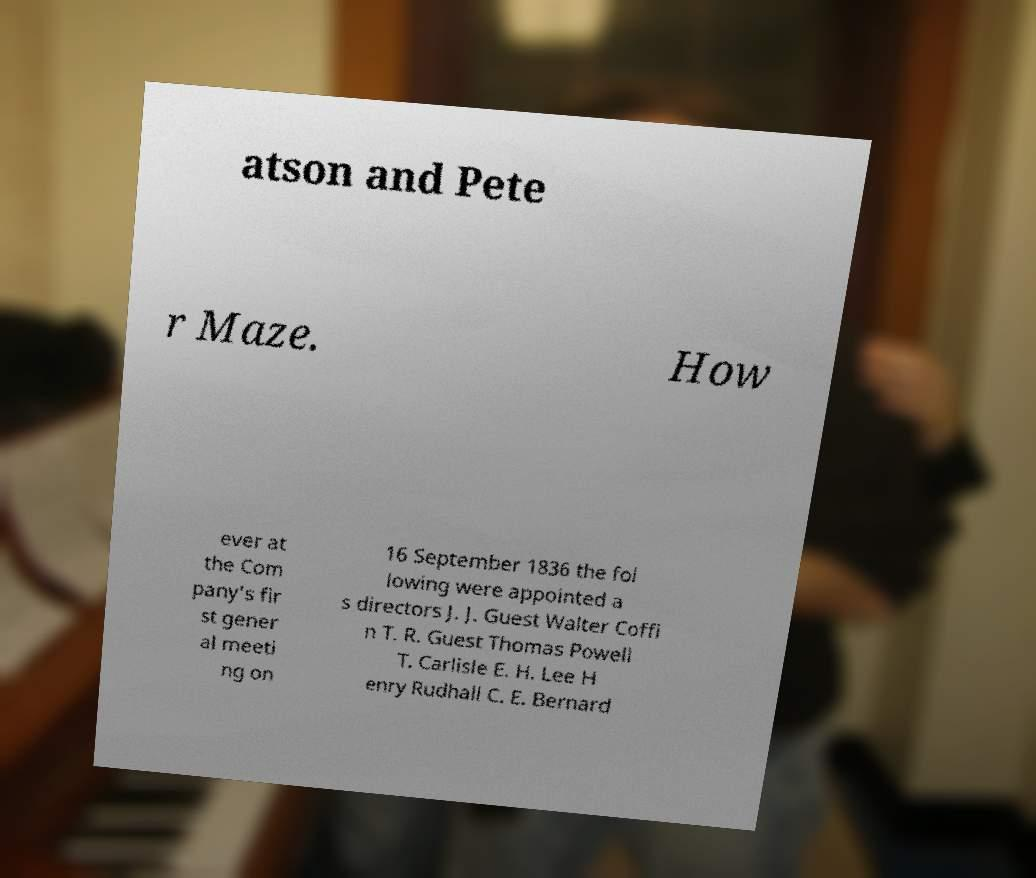I need the written content from this picture converted into text. Can you do that? atson and Pete r Maze. How ever at the Com pany's fir st gener al meeti ng on 16 September 1836 the fol lowing were appointed a s directors J. J. Guest Walter Coffi n T. R. Guest Thomas Powell T. Carlisle E. H. Lee H enry Rudhall C. E. Bernard 